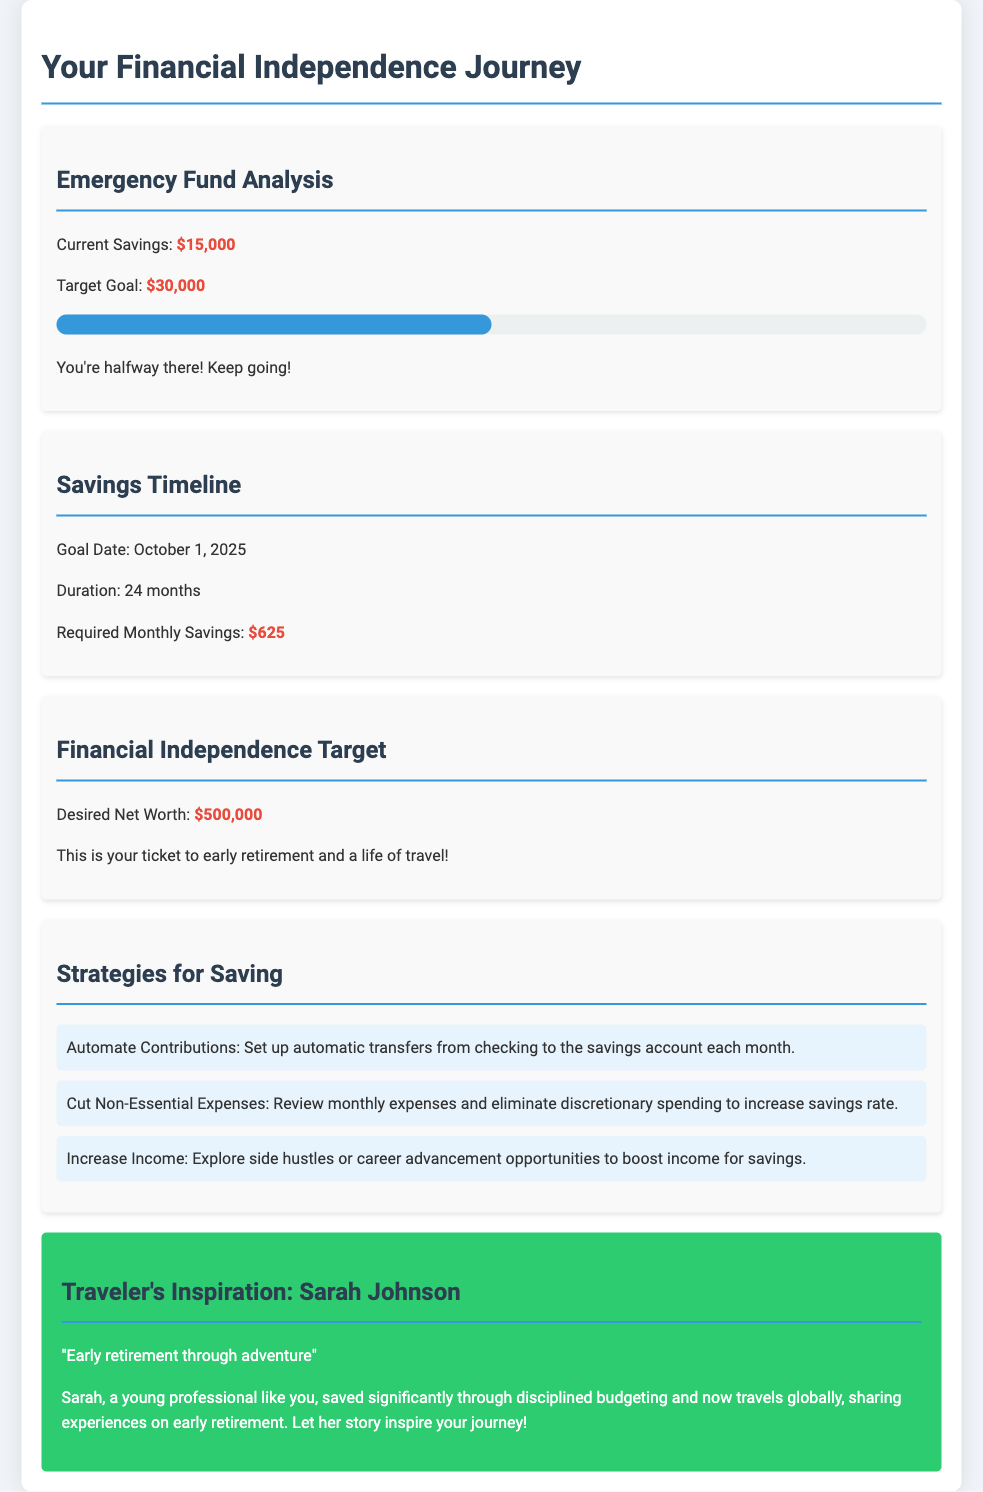What is the current savings amount? The current savings is stated clearly in the document as $15,000.
Answer: $15,000 What is the target goal for the emergency fund? The target goal for the emergency fund is specified as $30,000 in the document.
Answer: $30,000 What is the required monthly savings to reach the goal? The document outlines that the required monthly savings to achieve the goal is $625.
Answer: $625 What is the duration for achieving the savings goal? The timeline for achieving the savings goal is mentioned as 24 months.
Answer: 24 months What is the goal date for reaching the emergency fund target? The goal date for reaching the target is set for October 1, 2025.
Answer: October 1, 2025 What is the desired net worth for financial independence? The document mentions that the desired net worth for financial independence is $500,000.
Answer: $500,000 What is one suggested strategy for saving? The document lists several strategies; one of them is to automate contributions.
Answer: Automate Contributions How far along is the emergency fund progress? The document indicates that the progress is at 50% toward the goal.
Answer: 50% Who is the traveler mentioned for inspiration? The inspiration in the document comes from Sarah Johnson, who is featured for her story.
Answer: Sarah Johnson 